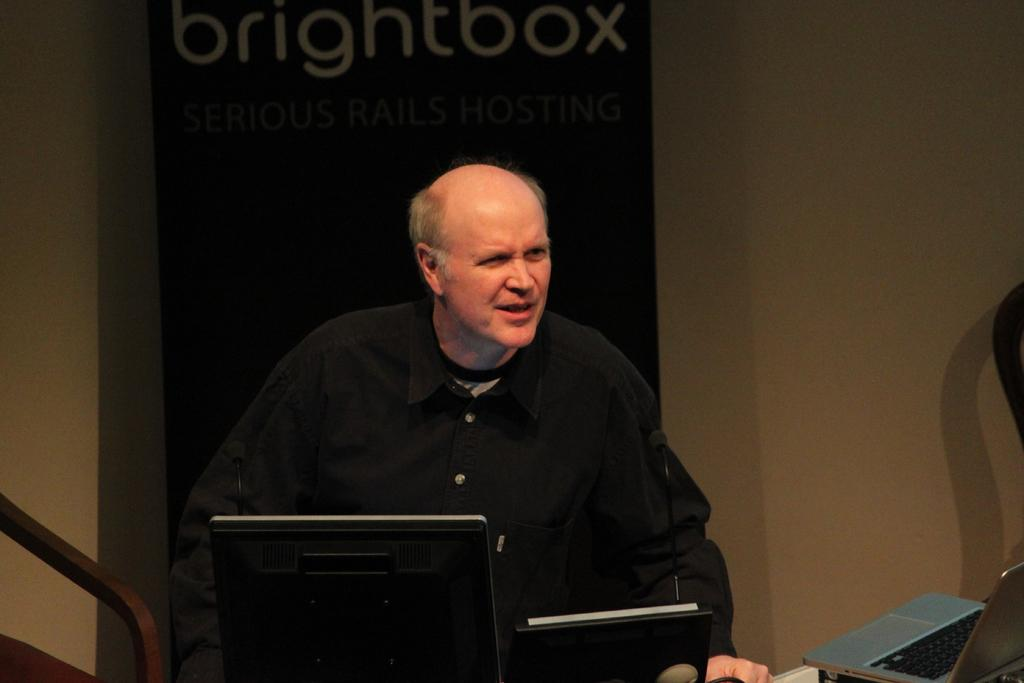Who or what is present in the image? There is a person in the image. What is the person wearing? The person is wearing a black dress. What else can be seen in the image besides the person? There are objects in the image. What is visible in the background of the image? There is a banner and a wall in the background of the image. What flavor of string can be seen hanging from the person's key in the image? There is no string or key present in the image, and therefore no such flavor can be observed. 